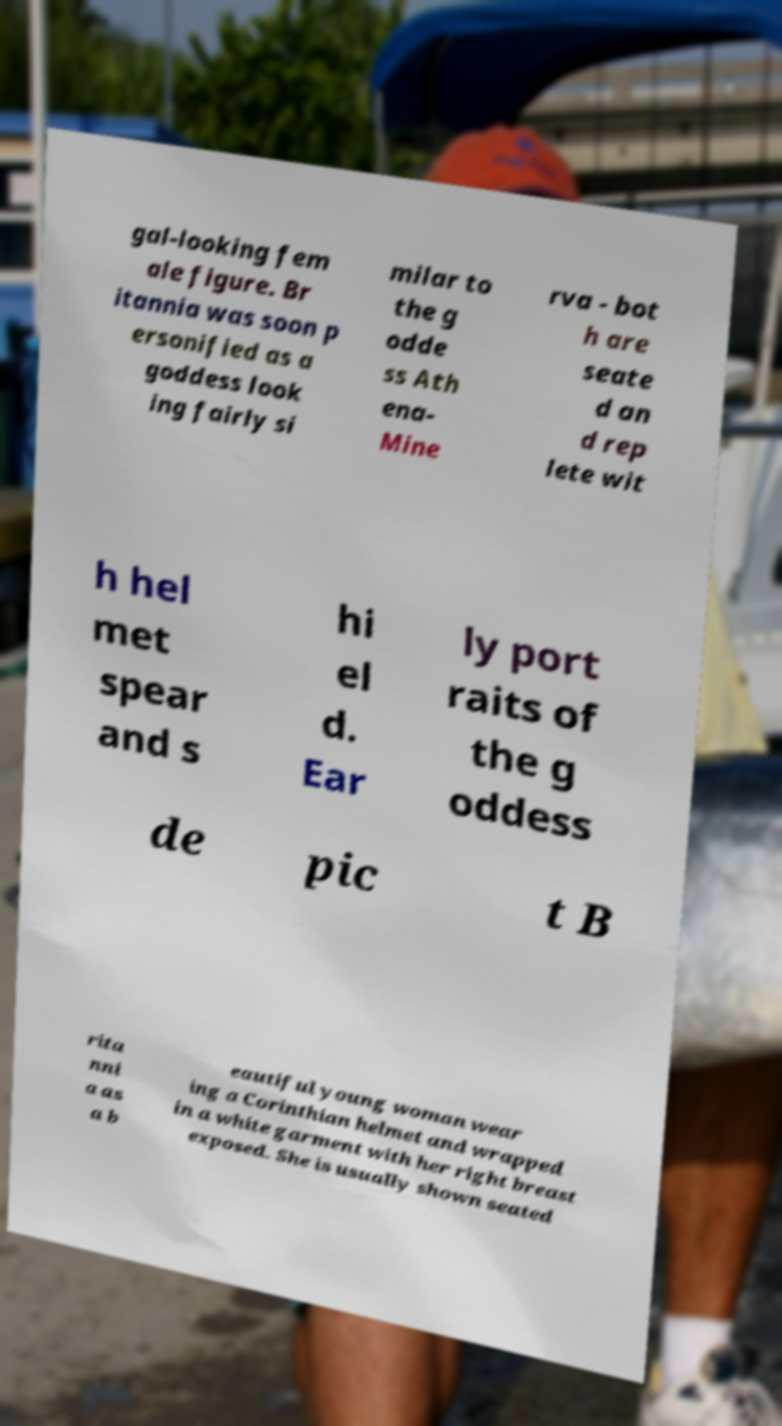What messages or text are displayed in this image? I need them in a readable, typed format. gal-looking fem ale figure. Br itannia was soon p ersonified as a goddess look ing fairly si milar to the g odde ss Ath ena- Mine rva - bot h are seate d an d rep lete wit h hel met spear and s hi el d. Ear ly port raits of the g oddess de pic t B rita nni a as a b eautiful young woman wear ing a Corinthian helmet and wrapped in a white garment with her right breast exposed. She is usually shown seated 